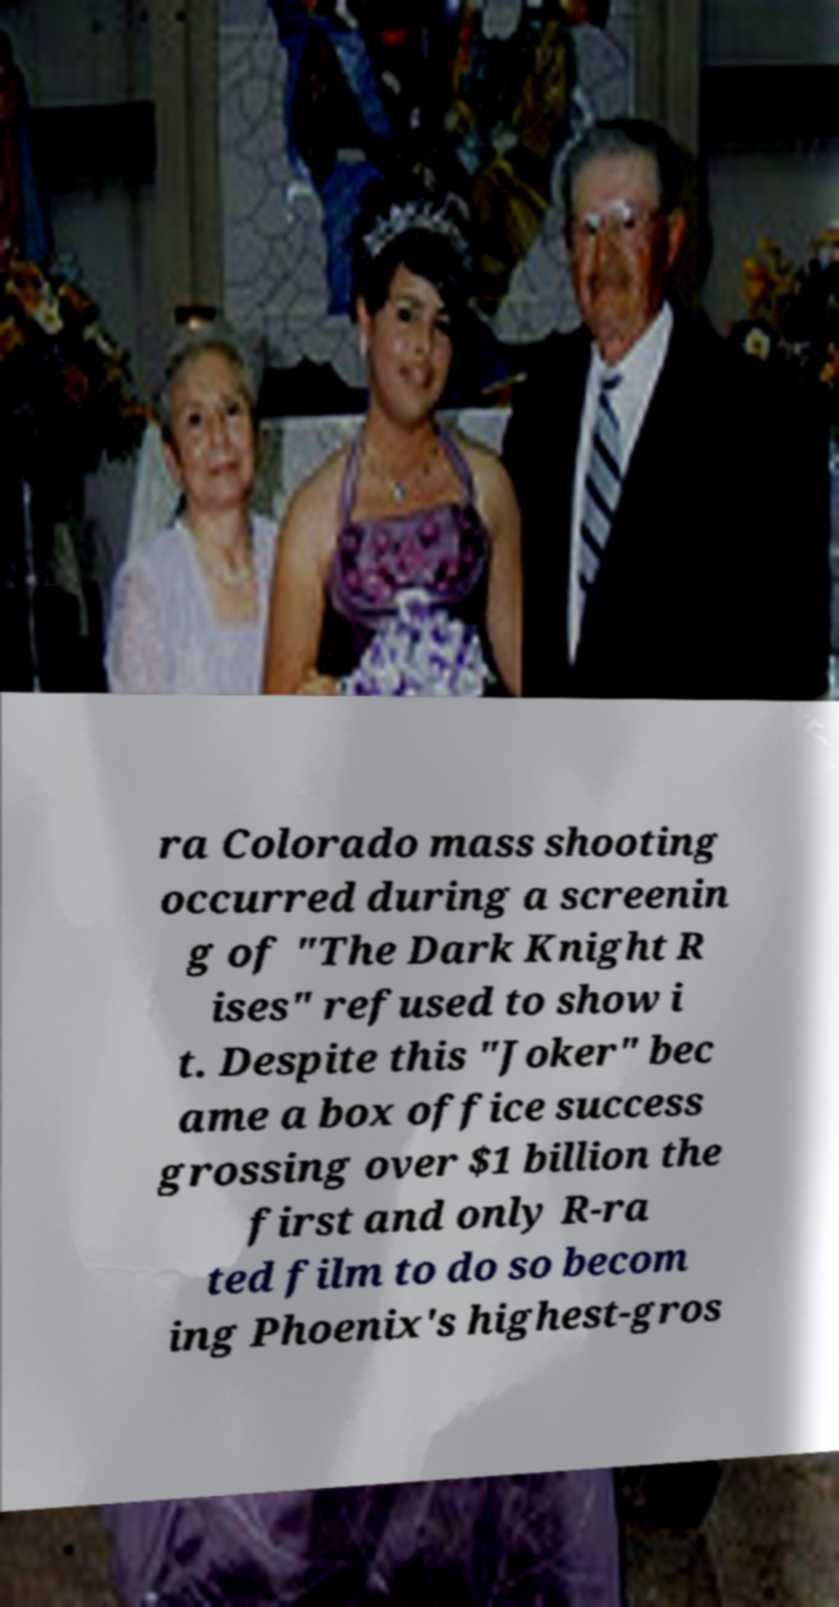What messages or text are displayed in this image? I need them in a readable, typed format. ra Colorado mass shooting occurred during a screenin g of "The Dark Knight R ises" refused to show i t. Despite this "Joker" bec ame a box office success grossing over $1 billion the first and only R-ra ted film to do so becom ing Phoenix's highest-gros 